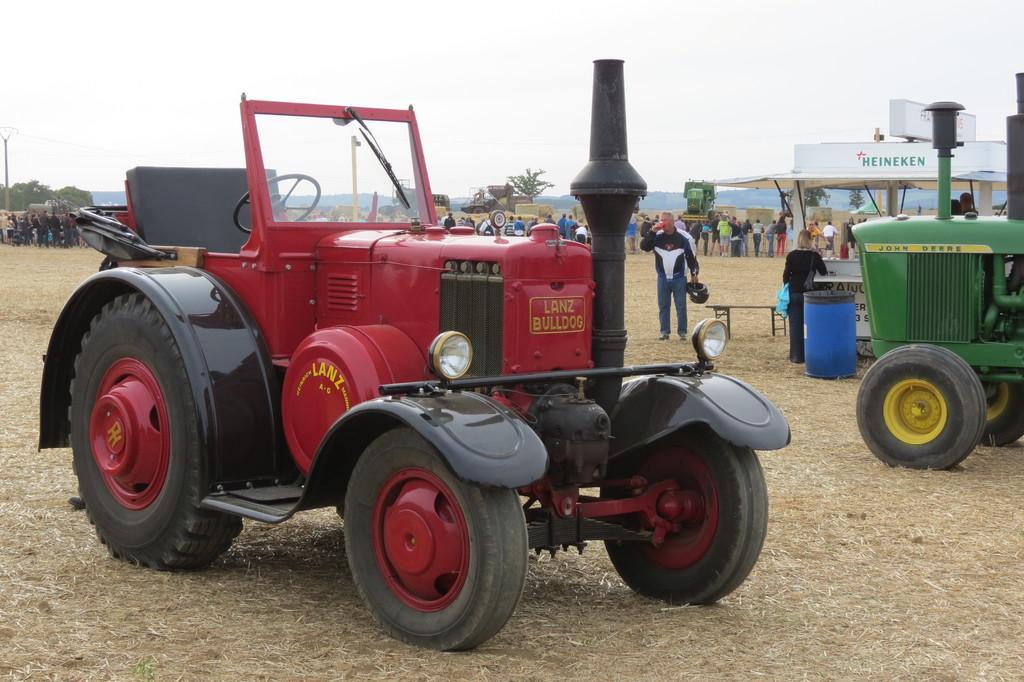Please provide a concise description of this image. It is an open land, there is a Heineken named shelter and in the front there are two tractors kept on the ground and behind the tractors there is queue of people in front of the Heineken shelter and beside the tractor there is a person standing and talking on phone, he is also holding a helmet in his other hand. 